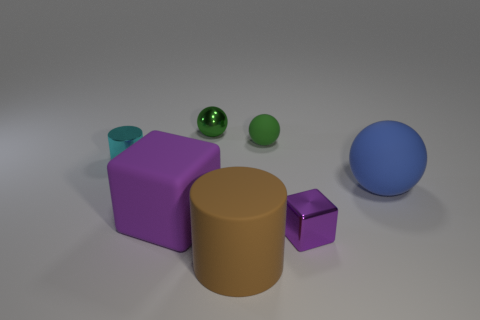How many other objects are the same size as the metal ball?
Keep it short and to the point. 3. The thing that is the same color as the metallic cube is what size?
Your answer should be very brief. Large. Do the metallic thing in front of the blue sphere and the large brown matte thing have the same shape?
Keep it short and to the point. No. There is a big object behind the large purple matte object; what is its material?
Give a very brief answer. Rubber. There is a big object that is the same color as the small metallic block; what is its shape?
Offer a terse response. Cube. Is there a small blue object made of the same material as the small cyan thing?
Your response must be concise. No. The matte cylinder is what size?
Make the answer very short. Large. What number of red things are metal things or large matte cylinders?
Your answer should be very brief. 0. How many large red metallic things have the same shape as the small green rubber object?
Make the answer very short. 0. How many shiny cylinders have the same size as the metal block?
Ensure brevity in your answer.  1. 